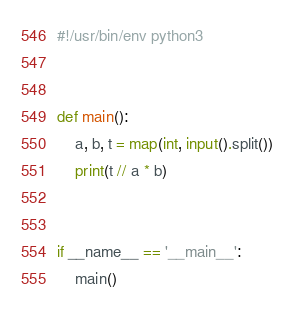<code> <loc_0><loc_0><loc_500><loc_500><_Python_>#!/usr/bin/env python3


def main():
    a, b, t = map(int, input().split())
    print(t // a * b)


if __name__ == '__main__':
    main()
</code> 